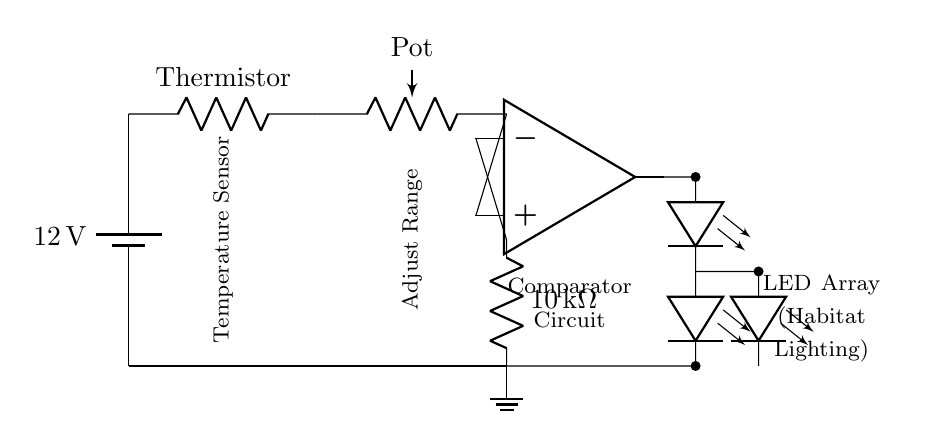What is the voltage of the power supply? The voltage of the power supply is indicated next to the battery symbol. This specific voltage is labeled as twelve volts.
Answer: twelve volts What type of component is connected to the thermistor? The component connected to the thermistor is a potentiometer, which is depicted with a label indicating its function. This connection shows that the thermistor is followed by this variable resistor.
Answer: potentiometer What is the purpose of the op-amp in this circuit? The op-amp is used in a comparator configuration. It compares voltages and controls the output based on the input from the thermistor and the potentiometer, affecting the LED behavior based on temperature.
Answer: comparator How many LEDs are shown in the circuit? The circuit diagram displays an array consisting of three LEDs. Two are connected directly, and one is part of a series string with another. You can count them visually in the LED sections.
Answer: three What is the resistance value labeled in the circuit? The resistance value indicated in the circuit is ten kilohms. This is clearly marked next to the resistor symbol that is connected to the inverting input of the op-amp.
Answer: ten kilohms What does the ground node indicate in the circuit? The ground node represents the reference point for the voltage in the circuit. All voltages are measured concerning this point, determining the operation of all components in the circuit.
Answer: reference point Which component measures temperature in the circuit? The thermistor serves as the temperature sensor in this circuit, allowing the monitoring of temperature and influencing the LED lighting according to temperature changes.
Answer: thermistor 